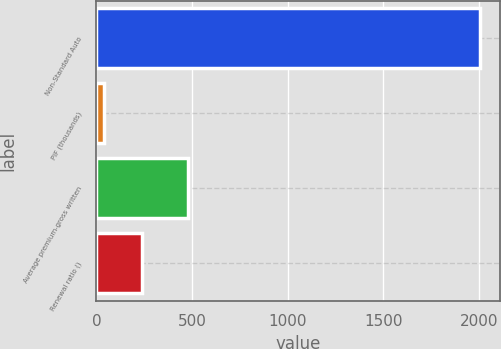<chart> <loc_0><loc_0><loc_500><loc_500><bar_chart><fcel>Non-Standard Auto<fcel>PIF (thousands)<fcel>Average premium-gross written<fcel>Renewal ratio ()<nl><fcel>2008<fcel>39<fcel>479<fcel>235.9<nl></chart> 